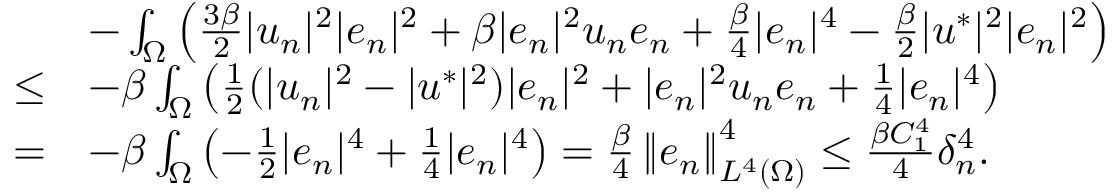Convert formula to latex. <formula><loc_0><loc_0><loc_500><loc_500>\begin{array} { r l } & { - \int _ { \Omega } \left ( \frac { 3 \beta } { 2 } | u _ { n } | ^ { 2 } | e _ { n } | ^ { 2 } + \beta | e _ { n } | ^ { 2 } u _ { n } e _ { n } + \frac { \beta } { 4 } | e _ { n } | ^ { 4 } - \frac { \beta } { 2 } | u ^ { * } | ^ { 2 } | e _ { n } | ^ { 2 } \right ) } \\ { \leq } & { - \beta \int _ { \Omega } \left ( \frac { 1 } { 2 } ( | u _ { n } | ^ { 2 } - | u ^ { * } | ^ { 2 } ) | e _ { n } | ^ { 2 } + | e _ { n } | ^ { 2 } u _ { n } e _ { n } + \frac { 1 } { 4 } | e _ { n } | ^ { 4 } \right ) } \\ { = } & { - \beta \int _ { \Omega } \left ( - \frac { 1 } { 2 } | e _ { n } | ^ { 4 } + \frac { 1 } { 4 } | e _ { n } | ^ { 4 } \right ) = \frac { \beta } { 4 } \left \| e _ { n } \right \| _ { L ^ { 4 } ( \Omega ) } ^ { 4 } \leq \frac { \beta C _ { 1 } ^ { 4 } } { 4 } \delta _ { n } ^ { 4 } . } \end{array}</formula> 